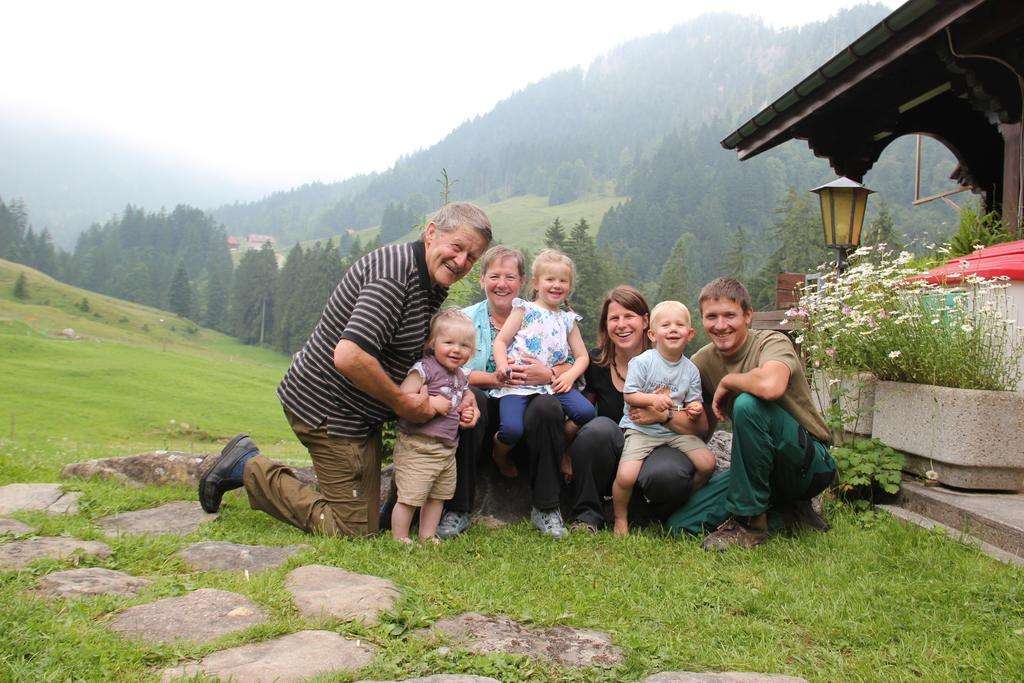What type of vegetation is present in the image? There is grass in the image. Can you describe the people in the image? There is a group of people in the image. What can be seen on the right side of the image? There are flowers on the right side of the image. What is visible in the background of the image? There are trees and the sky visible in the background of the image. Can you hear the whistle being blown in the image? There is no whistle present in the image, so it cannot be heard. What phase is the moon in the image? There is no moon present in the image. 